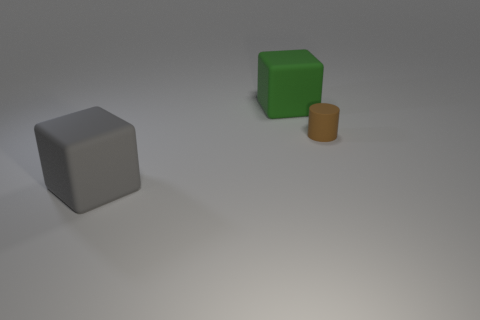Is there a big green metallic cube?
Make the answer very short. No. How many matte objects are behind the matte block on the left side of the big rubber thing behind the small brown cylinder?
Your answer should be compact. 2. Does the brown matte object have the same shape as the rubber object in front of the tiny brown cylinder?
Make the answer very short. No. Is the number of tiny green blocks greater than the number of large objects?
Your answer should be compact. No. Are there any other things that are the same size as the cylinder?
Keep it short and to the point. No. There is a big rubber object behind the tiny brown cylinder; is its shape the same as the large gray object?
Keep it short and to the point. Yes. Are there more big green cubes to the right of the green rubber cube than red cylinders?
Offer a very short reply. No. What color is the large matte block in front of the large block that is behind the big gray matte block?
Make the answer very short. Gray. What number of matte things are there?
Give a very brief answer. 3. What number of things are both in front of the big green object and left of the small matte cylinder?
Ensure brevity in your answer.  1. 